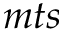Convert formula to latex. <formula><loc_0><loc_0><loc_500><loc_500>m t s</formula> 